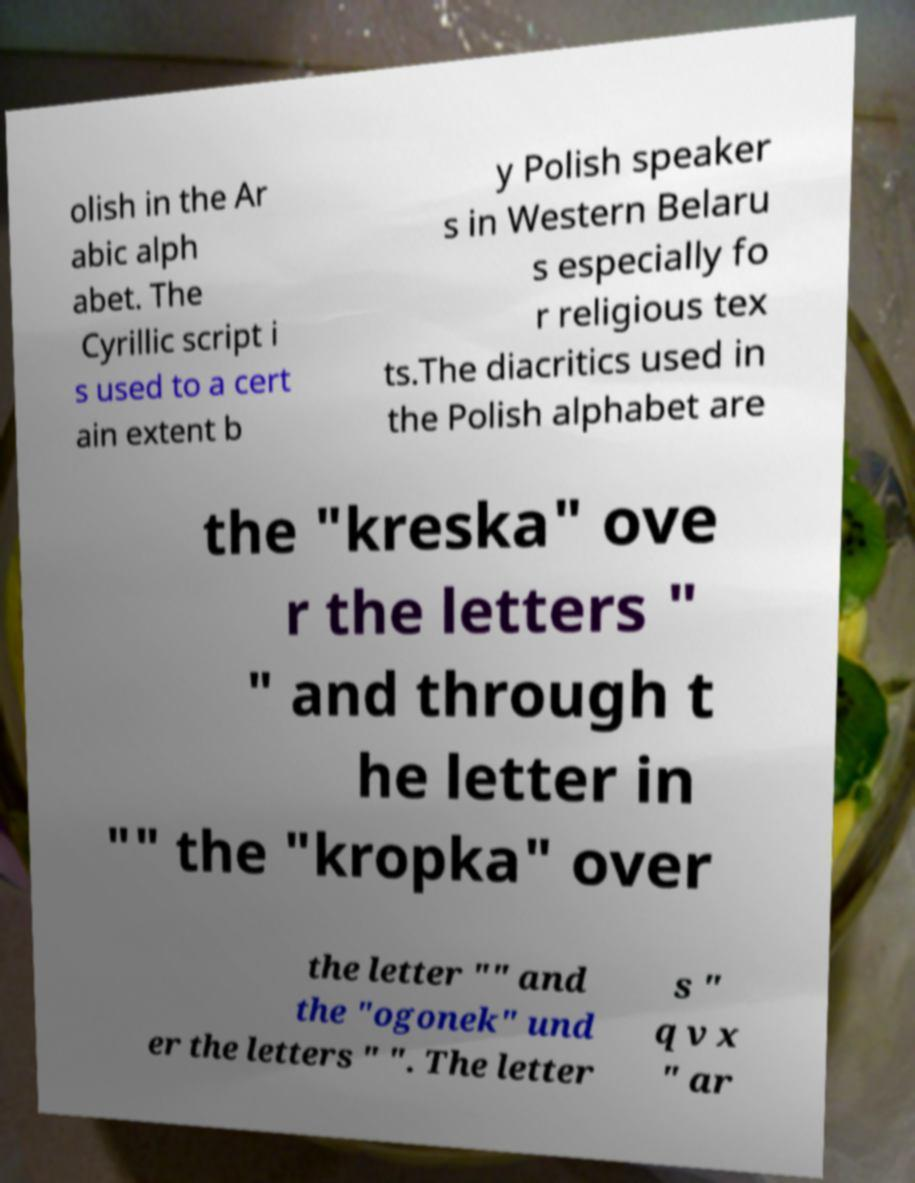Could you extract and type out the text from this image? olish in the Ar abic alph abet. The Cyrillic script i s used to a cert ain extent b y Polish speaker s in Western Belaru s especially fo r religious tex ts.The diacritics used in the Polish alphabet are the "kreska" ove r the letters " " and through t he letter in "" the "kropka" over the letter "" and the "ogonek" und er the letters " ". The letter s " q v x " ar 